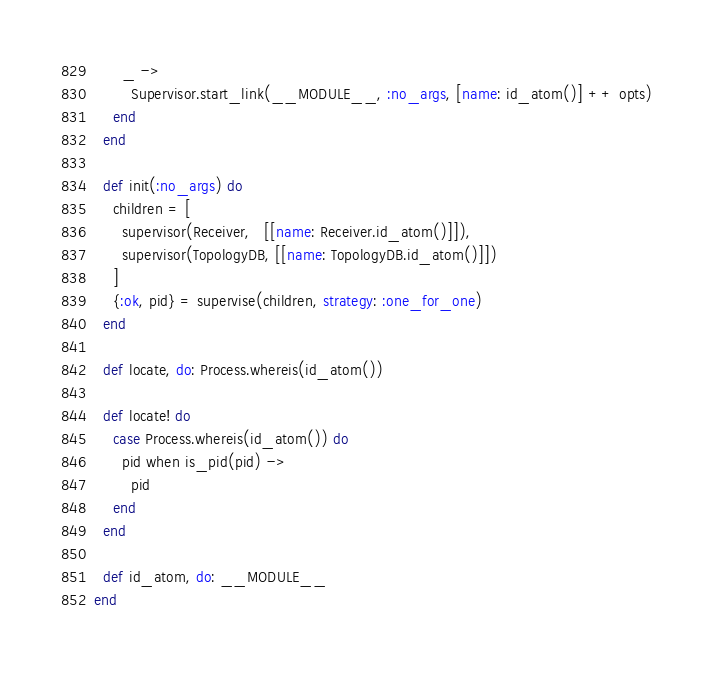<code> <loc_0><loc_0><loc_500><loc_500><_Elixir_>      _ ->
        Supervisor.start_link(__MODULE__, :no_args, [name: id_atom()] ++ opts)
    end
  end

  def init(:no_args) do
    children = [
      supervisor(Receiver,   [[name: Receiver.id_atom()]]),
      supervisor(TopologyDB, [[name: TopologyDB.id_atom()]])
    ]
    {:ok, pid} = supervise(children, strategy: :one_for_one)
  end

  def locate, do: Process.whereis(id_atom())

  def locate! do
    case Process.whereis(id_atom()) do
      pid when is_pid(pid) ->
        pid
    end
  end

  def id_atom, do: __MODULE__
end
</code> 